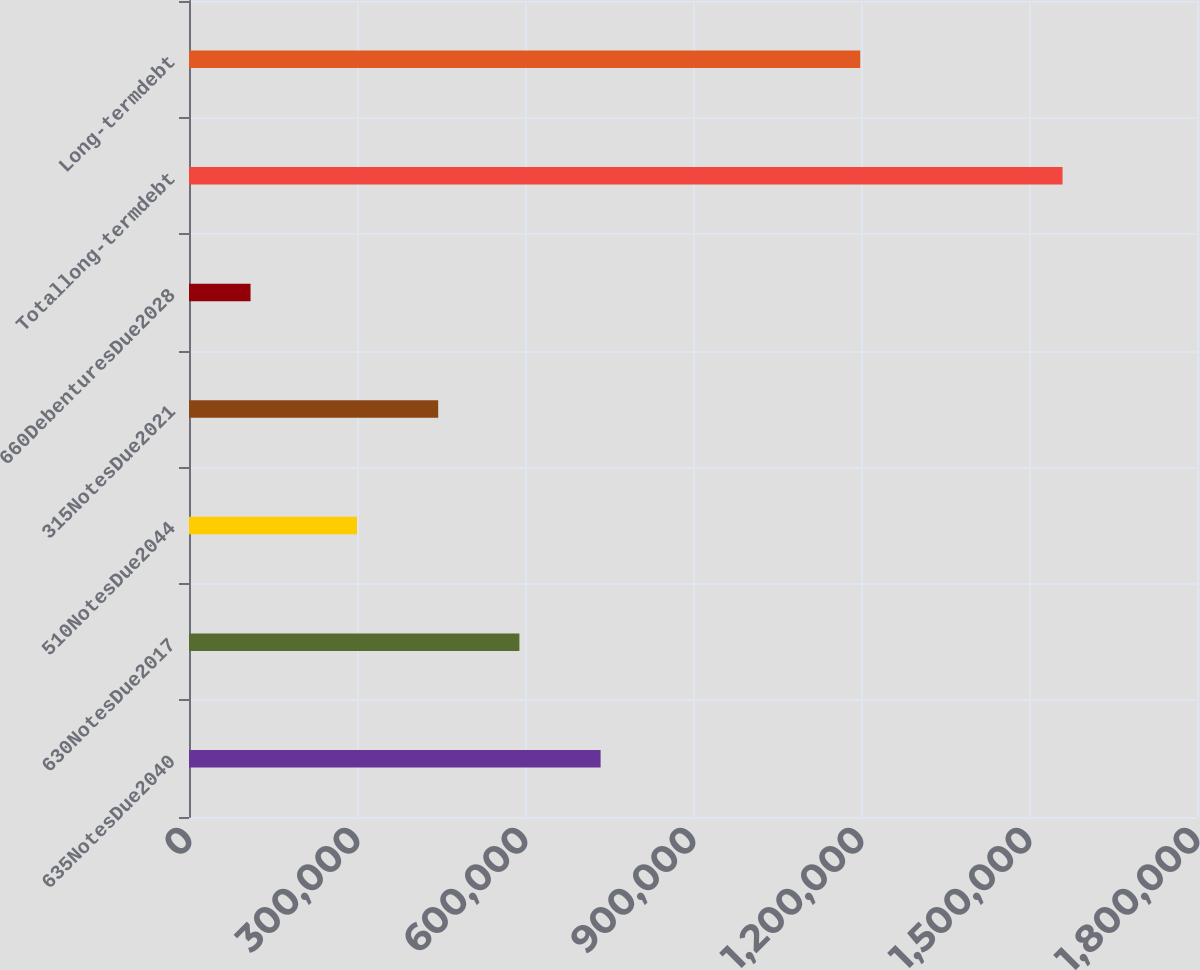Convert chart. <chart><loc_0><loc_0><loc_500><loc_500><bar_chart><fcel>635NotesDue2040<fcel>630NotesDue2017<fcel>510NotesDue2044<fcel>315NotesDue2021<fcel>660DebenturesDue2028<fcel>Totallong-termdebt<fcel>Long-termdebt<nl><fcel>735000<fcel>590000<fcel>300000<fcel>445000<fcel>109895<fcel>1.5599e+06<fcel>1.19868e+06<nl></chart> 